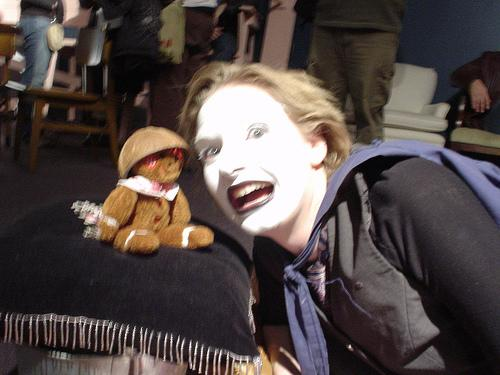What role does the black pillow with tassels play in the image's composition? The black pillow with tassels serves as a contrasting element and a resting place for the teddy bear, enhancing the image's intrigue. Provide a description of the teddy bear's appearance in the image. The teddy bear is brown, has red eyes, wearing a cape, a helmet, and a scarf. Count the number of distinct objects or subjects mentioned in the image description. 25 distinct objects or subjects. Which objects in the image have a similar color? Woman's face makeup and the white chair, woman's lips and the black pillow, teddy bear and woman's brown hair. Assess the quality of the image in terms of sharpness, lighting, and colors. The image has good sharpness and lighting, with a variety of colors such as white, black, brown, red, and blue. Write a short story about a party based on this image. At a not-so-scary Halloween party, a mime with white makeup, black lipstick, and light brown hair mesmerized guests with her wide-open eyes and animated expressions. Meanwhile, a mysterious brown teddy bear with red eyes, a cape, a helmet, and a scarf sat quietly on a black pillow. Explain whether the objects in the image are interacting and how. The woman (mime) and teddy bear are not directly interacting, but they share a space and contribute to the overall mood of the image. Evaluate the image's sentiment or mood. The image has an unusual and mysterious mood, possibly due to the mime and the teddy bear with red eyes. Describe the arrangement of objects in the image in relation to one another. A woman wearing white makeup and black lipstick is near a teddy bear sitting on a black pillow. A white chair and wooden chair are in the background, with people present. What colors can be associated with the woman in the image? White (face makeup and chair), black (lips and shirt), brown (hair). 